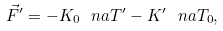<formula> <loc_0><loc_0><loc_500><loc_500>\vec { F } ^ { \prime } = - K _ { 0 } \ n a T ^ { \prime } - K ^ { \prime } \ n a T _ { 0 } ,</formula> 